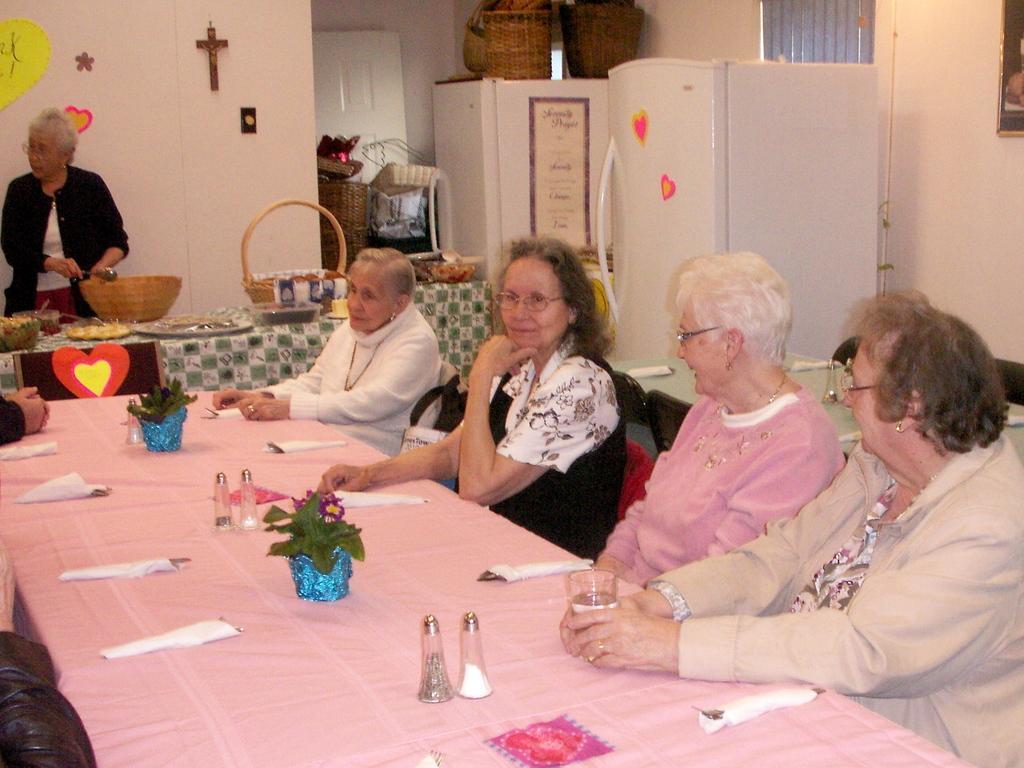Please provide a concise description of this image. This is an inside view of a room. In this picture we can see a refrigerator. We can see few stickers on the wall and refrigerator. On the right side of the picture we can see women sitting. We can see a woman holding a glass. On a table we can see cloth, tissue papers, plants and few objects. On the left side of the picture we can see the hands of the people. In the background we can see a table and a woman standing. She is wearing spectacles and holding a spoon. On a table we can see a cloth, plates, baskets and few objects. In the background we can see baskets on the white object. We can see a sticker on it. 